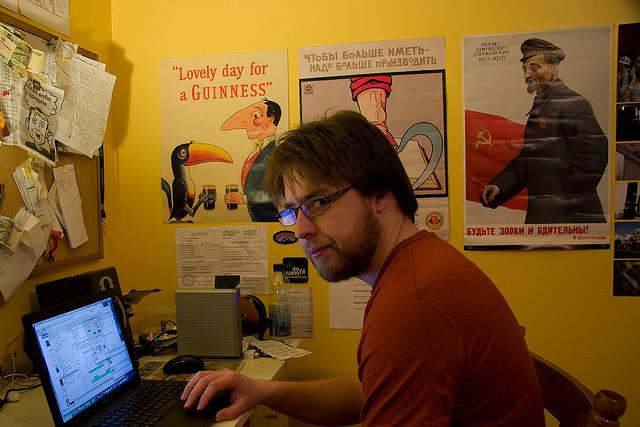What are the toucan and the man going to enjoy?

Choices:
A) soda
B) beer
C) some wine
D) some water beer 